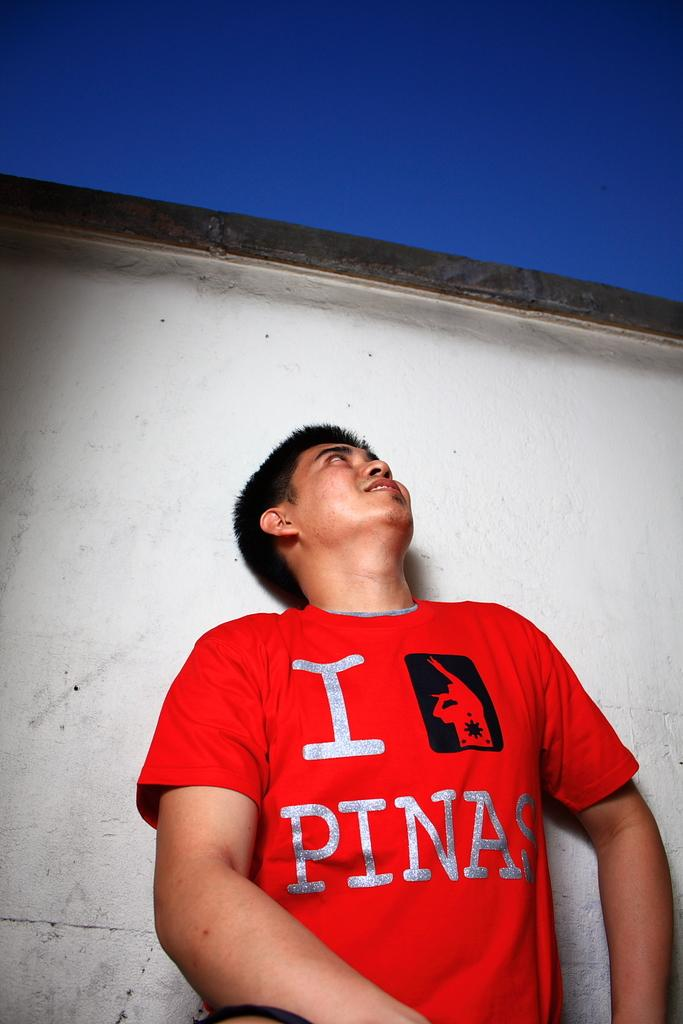<image>
Present a compact description of the photo's key features. A man wears a red "I Love Pinas" shirt. 